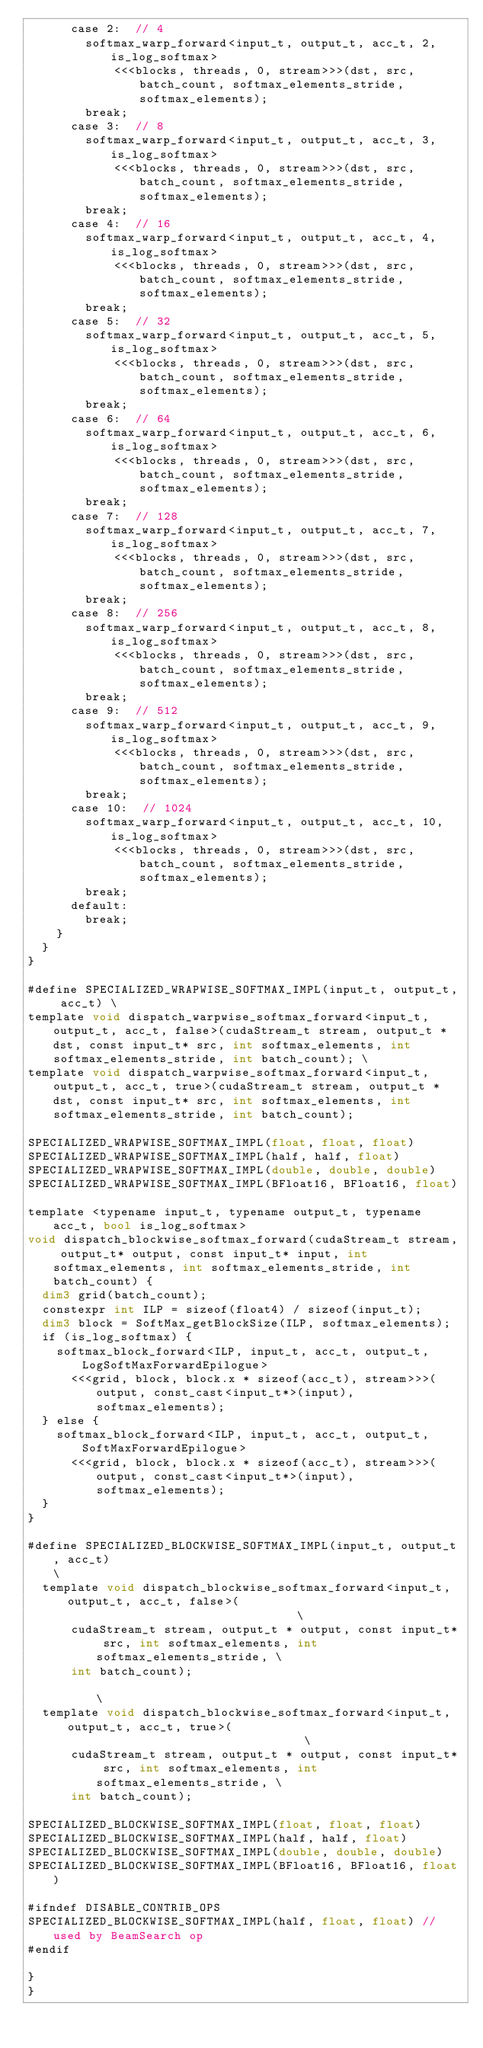<code> <loc_0><loc_0><loc_500><loc_500><_Cuda_>      case 2:  // 4
        softmax_warp_forward<input_t, output_t, acc_t, 2, is_log_softmax>
            <<<blocks, threads, 0, stream>>>(dst, src, batch_count, softmax_elements_stride, softmax_elements);
        break;
      case 3:  // 8
        softmax_warp_forward<input_t, output_t, acc_t, 3, is_log_softmax>
            <<<blocks, threads, 0, stream>>>(dst, src, batch_count, softmax_elements_stride, softmax_elements);
        break;
      case 4:  // 16
        softmax_warp_forward<input_t, output_t, acc_t, 4, is_log_softmax>
            <<<blocks, threads, 0, stream>>>(dst, src, batch_count, softmax_elements_stride, softmax_elements);
        break;
      case 5:  // 32
        softmax_warp_forward<input_t, output_t, acc_t, 5, is_log_softmax>
            <<<blocks, threads, 0, stream>>>(dst, src, batch_count, softmax_elements_stride, softmax_elements);
        break;
      case 6:  // 64
        softmax_warp_forward<input_t, output_t, acc_t, 6, is_log_softmax>
            <<<blocks, threads, 0, stream>>>(dst, src, batch_count, softmax_elements_stride, softmax_elements);
        break;
      case 7:  // 128
        softmax_warp_forward<input_t, output_t, acc_t, 7, is_log_softmax>
            <<<blocks, threads, 0, stream>>>(dst, src, batch_count, softmax_elements_stride, softmax_elements);
        break;
      case 8:  // 256
        softmax_warp_forward<input_t, output_t, acc_t, 8, is_log_softmax>
            <<<blocks, threads, 0, stream>>>(dst, src, batch_count, softmax_elements_stride, softmax_elements);
        break;
      case 9:  // 512
        softmax_warp_forward<input_t, output_t, acc_t, 9, is_log_softmax>
            <<<blocks, threads, 0, stream>>>(dst, src, batch_count, softmax_elements_stride, softmax_elements);
        break;
      case 10:  // 1024
        softmax_warp_forward<input_t, output_t, acc_t, 10, is_log_softmax>
            <<<blocks, threads, 0, stream>>>(dst, src, batch_count, softmax_elements_stride, softmax_elements);
        break;
      default:
        break;
    }
  }
}

#define SPECIALIZED_WRAPWISE_SOFTMAX_IMPL(input_t, output_t, acc_t) \
template void dispatch_warpwise_softmax_forward<input_t, output_t, acc_t, false>(cudaStream_t stream, output_t * dst, const input_t* src, int softmax_elements, int softmax_elements_stride, int batch_count); \
template void dispatch_warpwise_softmax_forward<input_t, output_t, acc_t, true>(cudaStream_t stream, output_t * dst, const input_t* src, int softmax_elements, int softmax_elements_stride, int batch_count);

SPECIALIZED_WRAPWISE_SOFTMAX_IMPL(float, float, float)
SPECIALIZED_WRAPWISE_SOFTMAX_IMPL(half, half, float)
SPECIALIZED_WRAPWISE_SOFTMAX_IMPL(double, double, double)
SPECIALIZED_WRAPWISE_SOFTMAX_IMPL(BFloat16, BFloat16, float)

template <typename input_t, typename output_t, typename acc_t, bool is_log_softmax>
void dispatch_blockwise_softmax_forward(cudaStream_t stream, output_t* output, const input_t* input, int softmax_elements, int softmax_elements_stride, int batch_count) {
  dim3 grid(batch_count);
  constexpr int ILP = sizeof(float4) / sizeof(input_t);
  dim3 block = SoftMax_getBlockSize(ILP, softmax_elements);
  if (is_log_softmax) {
    softmax_block_forward<ILP, input_t, acc_t, output_t, LogSoftMaxForwardEpilogue>
      <<<grid, block, block.x * sizeof(acc_t), stream>>>(output, const_cast<input_t*>(input), softmax_elements);
  } else {
    softmax_block_forward<ILP, input_t, acc_t, output_t, SoftMaxForwardEpilogue>
      <<<grid, block, block.x * sizeof(acc_t), stream>>>(output, const_cast<input_t*>(input), softmax_elements);
  }
}

#define SPECIALIZED_BLOCKWISE_SOFTMAX_IMPL(input_t, output_t, acc_t)                                                 \
  template void dispatch_blockwise_softmax_forward<input_t, output_t, acc_t, false>(                                 \
      cudaStream_t stream, output_t * output, const input_t* src, int softmax_elements, int softmax_elements_stride, \
      int batch_count);                                                                                              \
  template void dispatch_blockwise_softmax_forward<input_t, output_t, acc_t, true>(                                  \
      cudaStream_t stream, output_t * output, const input_t* src, int softmax_elements, int softmax_elements_stride, \
      int batch_count);

SPECIALIZED_BLOCKWISE_SOFTMAX_IMPL(float, float, float)
SPECIALIZED_BLOCKWISE_SOFTMAX_IMPL(half, half, float)
SPECIALIZED_BLOCKWISE_SOFTMAX_IMPL(double, double, double)
SPECIALIZED_BLOCKWISE_SOFTMAX_IMPL(BFloat16, BFloat16, float)

#ifndef DISABLE_CONTRIB_OPS
SPECIALIZED_BLOCKWISE_SOFTMAX_IMPL(half, float, float) // used by BeamSearch op
#endif

}
}
</code> 